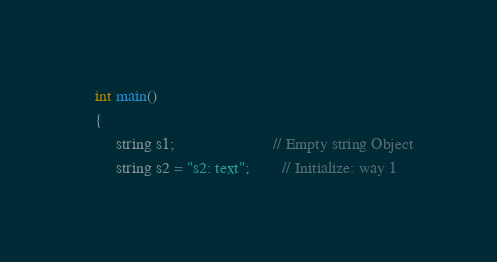<code> <loc_0><loc_0><loc_500><loc_500><_C++_>   int main()
   {  
		string s1; 						// Empty string Object
		string s2 = "s2: text"; 		// Initialize: way 1</code> 